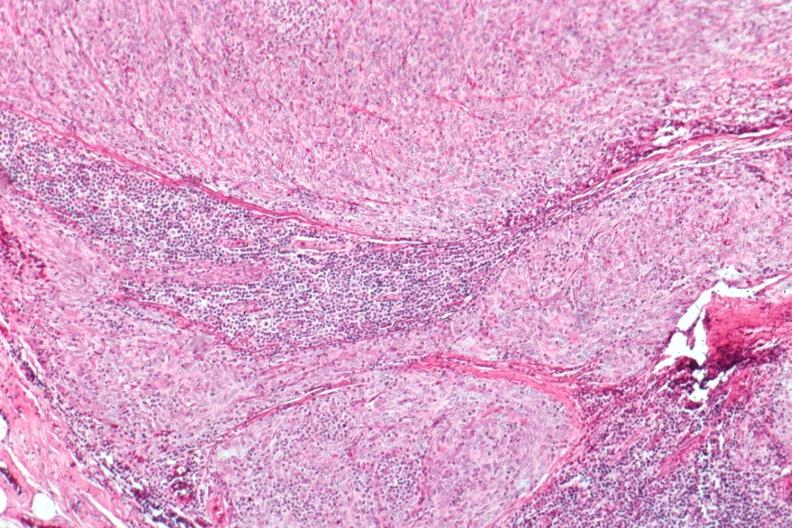what is present?
Answer the question using a single word or phrase. Thymus 